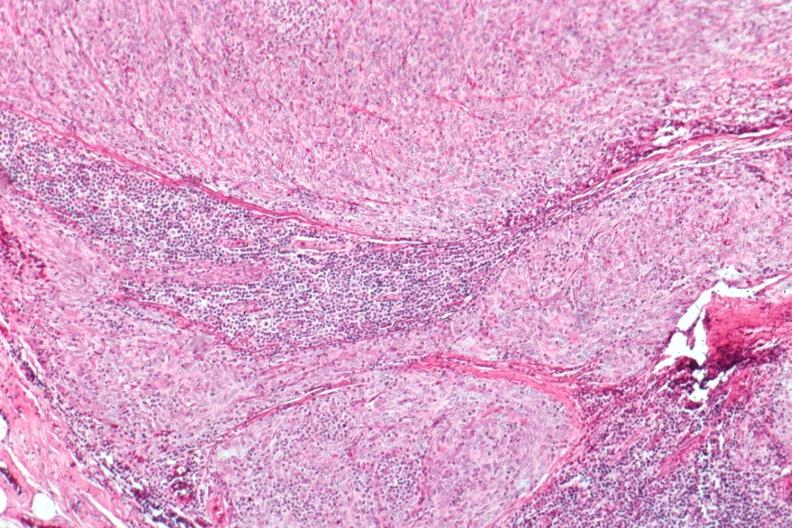what is present?
Answer the question using a single word or phrase. Thymus 